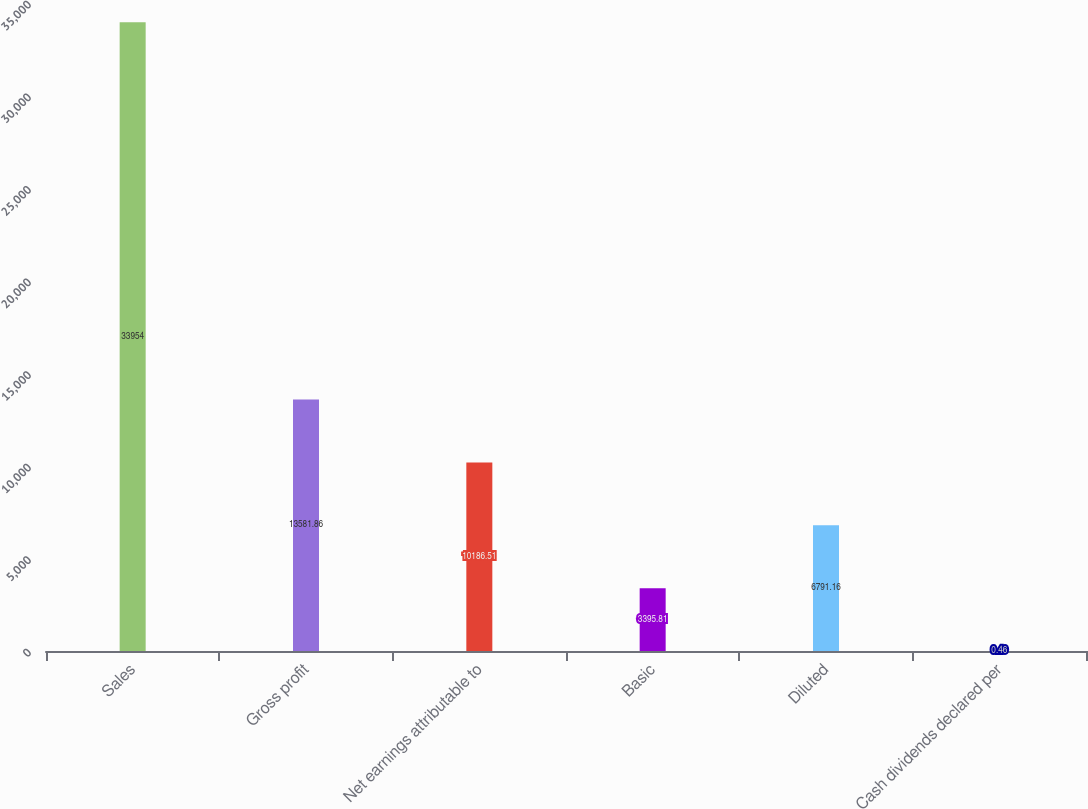Convert chart. <chart><loc_0><loc_0><loc_500><loc_500><bar_chart><fcel>Sales<fcel>Gross profit<fcel>Net earnings attributable to<fcel>Basic<fcel>Diluted<fcel>Cash dividends declared per<nl><fcel>33954<fcel>13581.9<fcel>10186.5<fcel>3395.81<fcel>6791.16<fcel>0.46<nl></chart> 